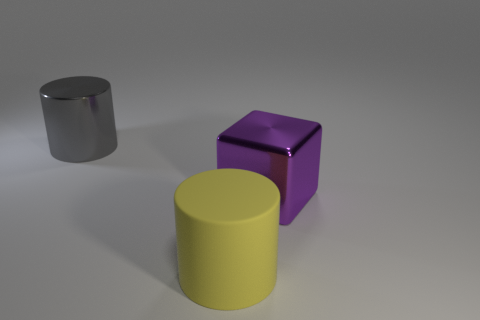Is there anything else that has the same material as the yellow cylinder?
Your answer should be compact. No. Does the purple metallic thing have the same size as the gray cylinder?
Give a very brief answer. Yes. How many things are rubber things to the right of the gray metal cylinder or big objects left of the metallic cube?
Your answer should be very brief. 2. What number of big purple metallic blocks are in front of the big cylinder that is right of the big thing on the left side of the matte cylinder?
Your answer should be very brief. 0. There is a cylinder that is in front of the gray cylinder; how big is it?
Provide a short and direct response. Large. How many blue metallic cubes are the same size as the yellow cylinder?
Offer a terse response. 0. There is a purple metallic object; does it have the same size as the thing that is behind the purple metallic block?
Provide a short and direct response. Yes. What number of things are either big gray matte cylinders or big gray metal objects?
Make the answer very short. 1. How many other big blocks are the same color as the shiny cube?
Provide a succinct answer. 0. There is a gray thing that is the same size as the purple object; what shape is it?
Give a very brief answer. Cylinder. 